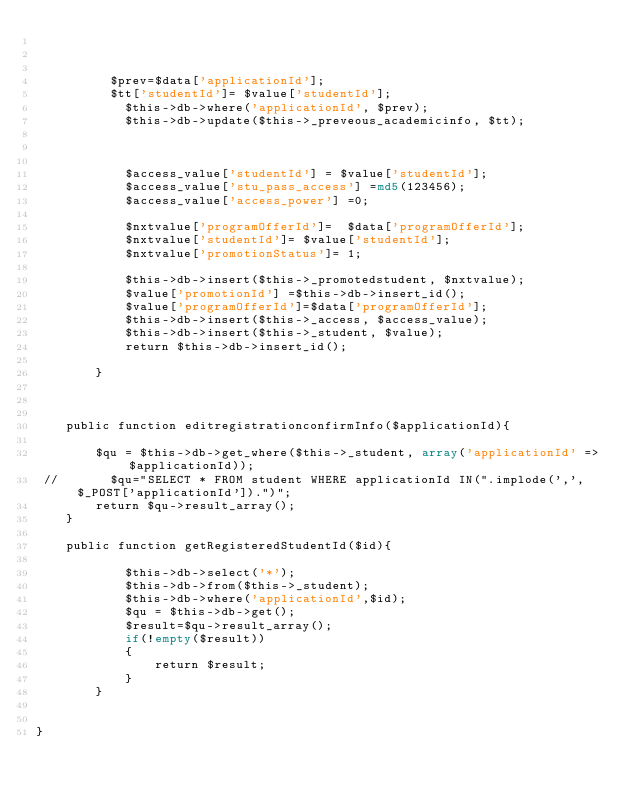<code> <loc_0><loc_0><loc_500><loc_500><_PHP_>            
     
            
          $prev=$data['applicationId'];
          $tt['studentId']= $value['studentId'];
            $this->db->where('applicationId', $prev);
            $this->db->update($this->_preveous_academicinfo, $tt);
         
           
           
            $access_value['studentId'] = $value['studentId'];
            $access_value['stu_pass_access'] =md5(123456);
            $access_value['access_power'] =0;
            
            $nxtvalue['programOfferId']=  $data['programOfferId'];
            $nxtvalue['studentId']= $value['studentId'];
            $nxtvalue['promotionStatus']= 1;
           
            $this->db->insert($this->_promotedstudent, $nxtvalue);
            $value['promotionId'] =$this->db->insert_id();
            $value['programOfferId']=$data['programOfferId'];
            $this->db->insert($this->_access, $access_value);
            $this->db->insert($this->_student, $value);          
            return $this->db->insert_id();      
       
        }
    
   
   
    public function editregistrationconfirmInfo($applicationId){
        
        $qu = $this->db->get_where($this->_student, array('applicationId' => $applicationId));
 //       $qu="SELECT * FROM student WHERE applicationId IN(".implode(',',$_POST['applicationId']).")";
        return $qu->result_array(); 
    }
 
    public function getRegisteredStudentId($id){
        
            $this->db->select('*');
            $this->db->from($this->_student);
            $this->db->where('applicationId',$id);
            $qu = $this->db->get();
            $result=$qu->result_array();
            if(!empty($result))
            {
                return $result;
            }   
        }
    
    
}


</code> 